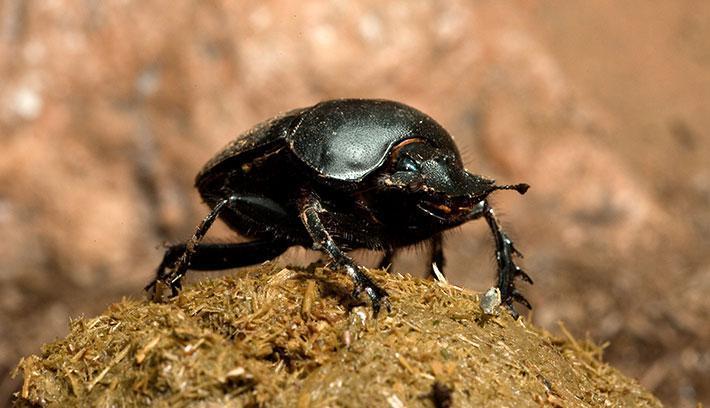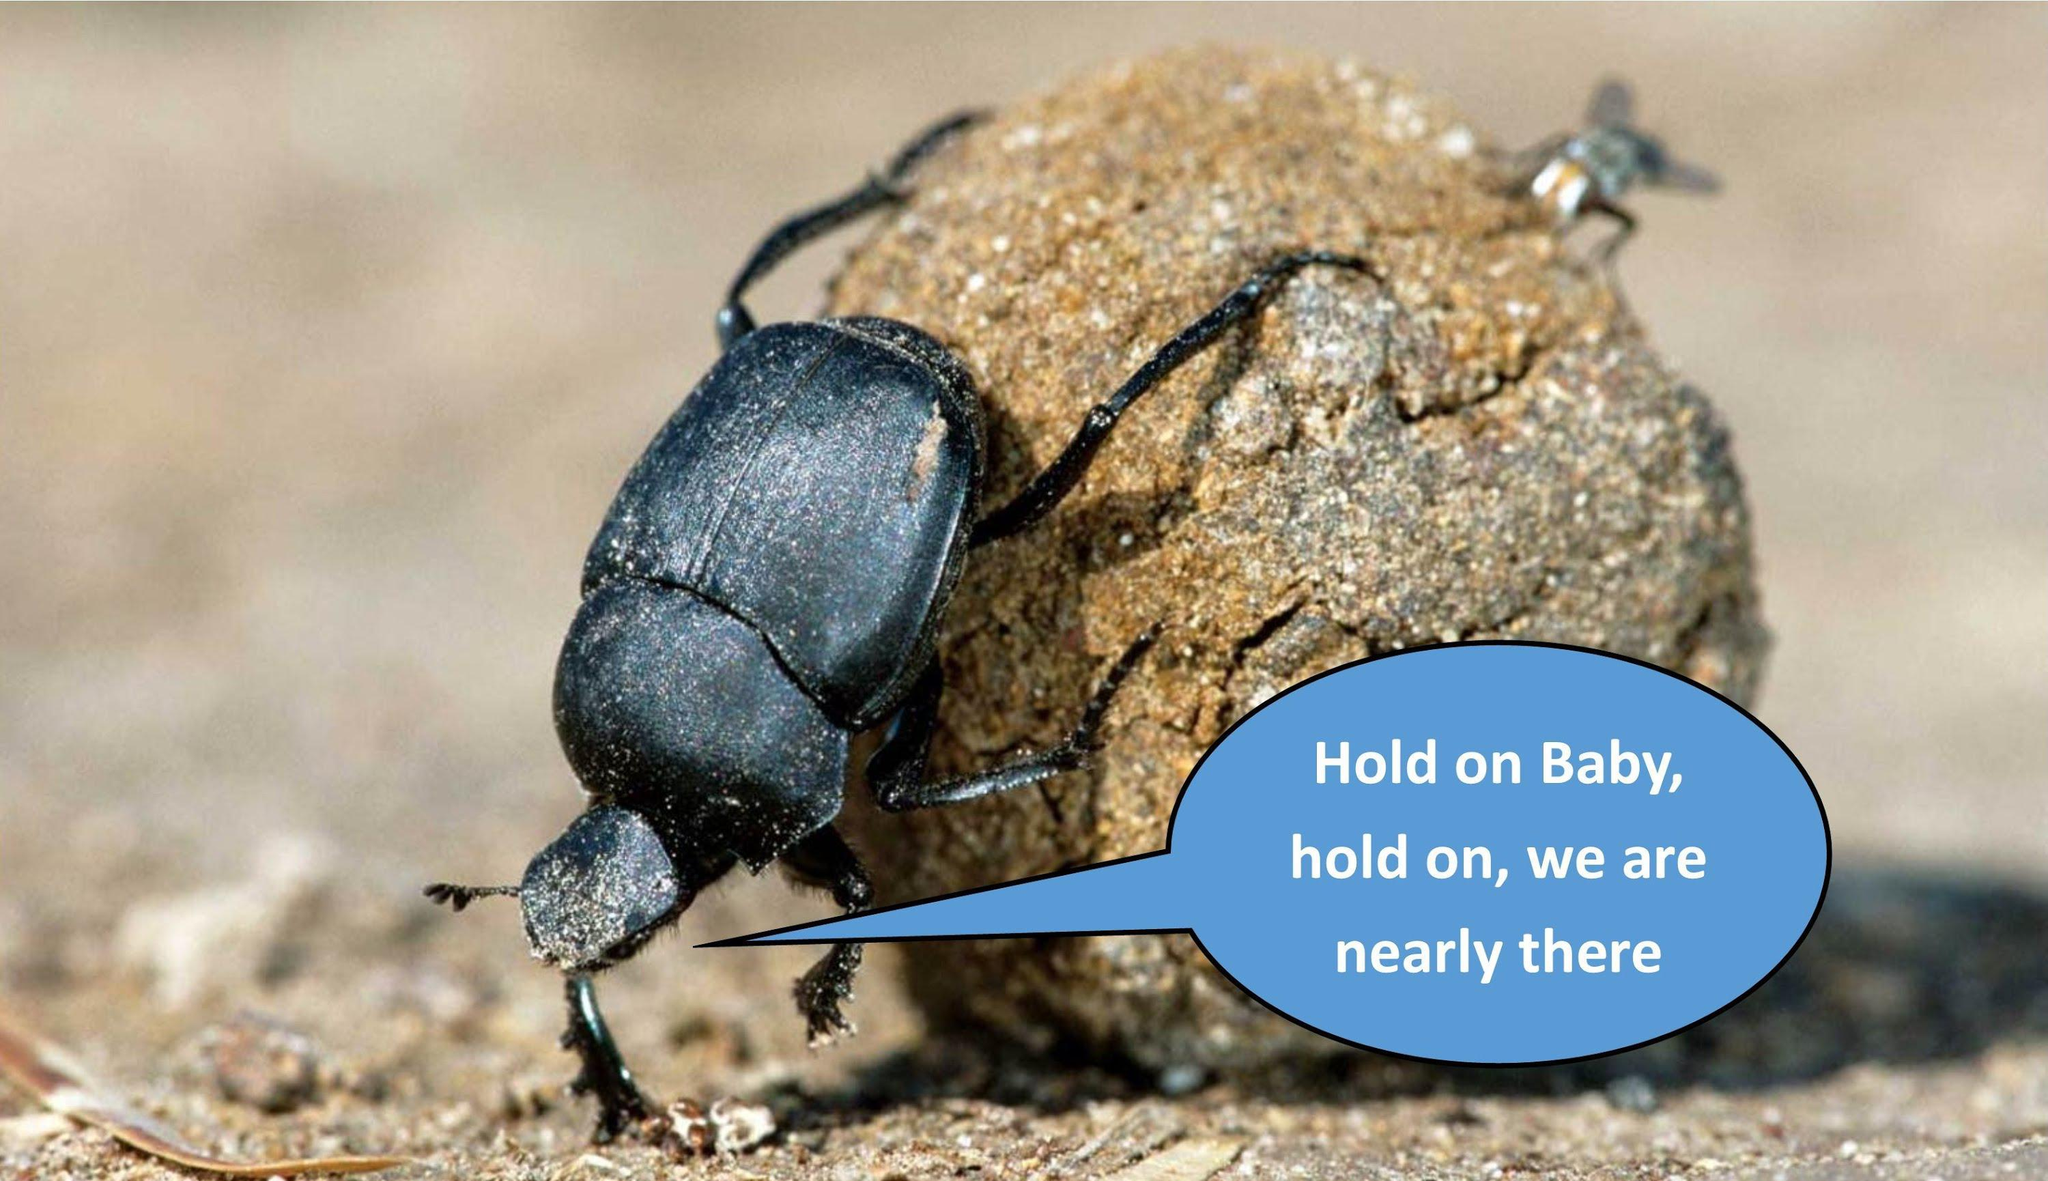The first image is the image on the left, the second image is the image on the right. For the images shown, is this caption "The image on the left contains exactly one insect." true? Answer yes or no. Yes. 